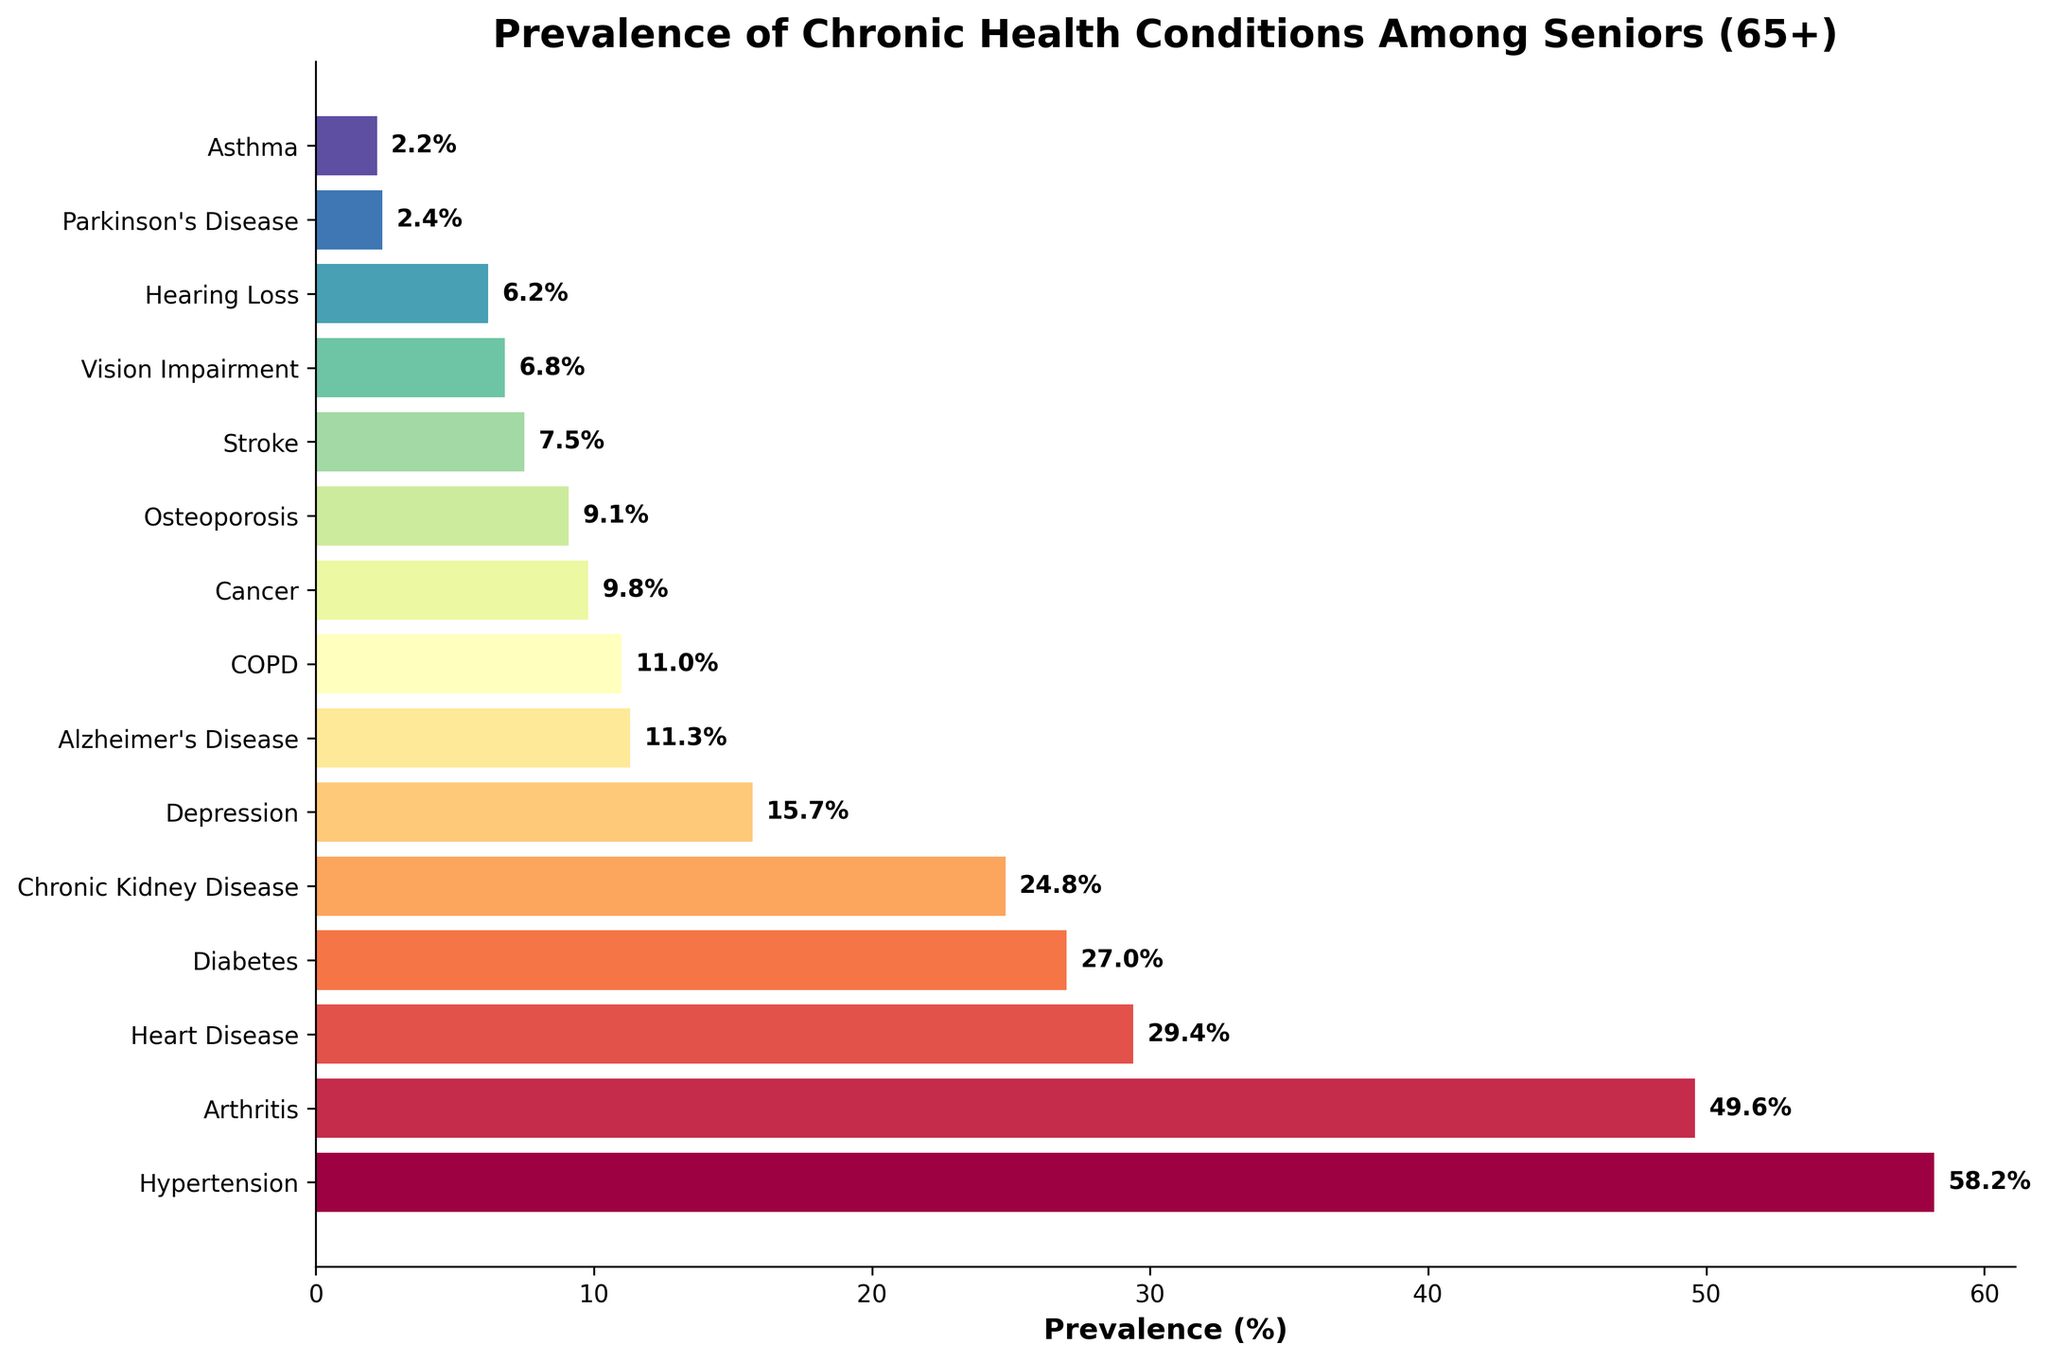Which chronic health condition has the highest prevalence among seniors aged 65+? The figure shows a horizontal bar chart with various health conditions and their corresponding prevalence percentages. The longest bar corresponds to "Hypertension" with a prevalence of 58.2%.
Answer: Hypertension Which condition has a lower prevalence: Alzheimer's Disease or COPD? By comparing the lengths of the bars, "Alzheimer's Disease" has a prevalence of 11.3% while "COPD" has a prevalence of 11.0%. Since 11.0% is lower than 11.3%, COPD has a lower prevalence.
Answer: COPD What is the combined prevalence of Heart Disease, Diabetes, and Chronic Kidney Disease among seniors aged 65+? The prevalence percentages for these conditions are 29.4% for Heart Disease, 27.0% for Diabetes, and 24.8% for Chronic Kidney Disease. Adding these up gives 29.4 + 27.0 + 24.8 = 81.2%.
Answer: 81.2% How much higher is the prevalence of Hypertension compared to that of Arthritis? The prevalence of Hypertension is 58.2%, and the prevalence of Arthritis is 49.6%. The difference is calculated as 58.2 - 49.6 = 8.6%.
Answer: 8.6% Which conditions have a prevalence below 10%? Focusing on the bars with prevalence percentages below 10%, the conditions are Cancer (9.8%), Osteoporosis (9.1%), Stroke (7.5%), Vision Impairment (6.8%), Hearing Loss (6.2%), Parkinson's Disease (2.4%), and Asthma (2.2%).
Answer: Cancer, Osteoporosis, Stroke, Vision Impairment, Hearing Loss, Parkinson's Disease, Asthma What is the average prevalence of all listed conditions? First, sum all the prevalence percentages: 58.2 + 49.6 + 29.4 + 27.0 + 24.8 + 15.7 + 11.3 + 11.0 + 9.8 + 9.1 + 7.5 + 6.8 + 6.2 + 2.4 + 2.2 = 271.0. There are 15 conditions, so the average is 271.0 / 15 = 18.07%.
Answer: 18.07% Which condition has approximately half the prevalence of Depression? Depression has a prevalence of 15.7%. Half of 15.7% is approximately 7.85%. According to the chart, Stroke has a prevalence of 7.5%, which is closest to half of 15.7%.
Answer: Stroke Rank Heart Disease, Chronic Kidney Disease, and Diabetes from highest to lowest prevalence. Based on the prevalence percentages listed in the chart, Heart Disease has 29.4%, Diabetes has 27.0%, and Chronic Kidney Disease has 24.8%. Therefore, the order from highest to lowest is Heart Disease, Diabetes, and Chronic Kidney Disease.
Answer: Heart Disease, Diabetes, Chronic Kidney Disease If the prevalence of Hypertension were to increase by 5%, what would the new prevalence be? The current prevalence of Hypertension is 58.2%. Adding 5% to this gives 58.2 + 5 = 63.2%.
Answer: 63.2% 